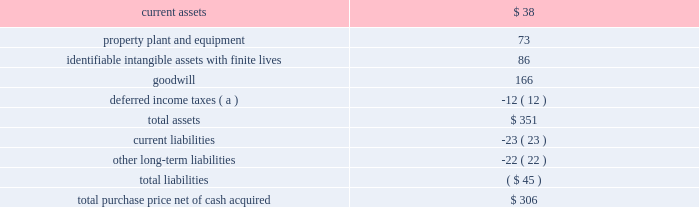58 2018 ppg annual report and 10-k the crown group on october 2 , 2017 , ppg acquired the crown group ( 201ccrown 201d ) , a u.s.-based coatings application services business , which is reported as part of ppg's industrial coatings reportable segment .
Crown is one of the leading component and product finishers in north america .
Crown applies coatings to customers 2019 manufactured parts and assembled products at 11 u.s .
Sites .
Most of crown 2019s facilities , which also provide assembly , warehousing and sequencing services , are located at customer facilities or positioned near customer manufacturing sites .
The company serves manufacturers in the automotive , agriculture , construction , heavy truck and alternative energy industries .
The pro-forma impact on ppg's sales and results of operations , including the pro forma effect of events that are directly attributable to the acquisition , was not significant .
The results of this business since the date of acquisition have been reported within the industrial coatings business within the industrial coatings reportable segment .
Taiwan chlorine industries taiwan chlorine industries ( 201ctci 201d ) was established in 1986 as a joint venture between ppg and china petrochemical development corporation ( 201ccpdc 201d ) to produce chlorine-based products in taiwan , at which time ppg owned 60 percent of the venture .
In conjunction with the 2013 separation of its commodity chemicals business , ppg conveyed to axiall corporation ( "axiall" ) its 60% ( 60 % ) ownership interest in tci .
Under ppg 2019s agreement with cpdc , if certain post-closing conditions were not met following the three year anniversary of the separation , cpdc had the option to sell its 40% ( 40 % ) ownership interest in tci to axiall for $ 100 million .
In turn , axiall had a right to designate ppg as its designee to purchase the 40% ( 40 % ) ownership interest of cpdc .
In april 2016 , axiall announced that cpdc had decided to sell its ownership interest in tci to axiall .
In june 2016 , axiall formally designated ppg to purchase the 40% ( 40 % ) ownership interest in tci .
In august 2016 , westlake chemical corporation acquired axiall , which became a wholly-owned subsidiary of westlake .
In april 2017 , ppg finalized its purchase of cpdc 2019s 40% ( 40 % ) ownership interest in tci .
The difference between the acquisition date fair value and the purchase price of ppg 2019s 40% ( 40 % ) ownership interest in tci has been recorded as a loss in discontinued operations during the year-ended december 31 , 2017 .
Ppg 2019s ownership in tci is accounted for as an equity method investment and the related equity earnings are reported within other income in the consolidated statement of income and in legacy in note 20 , 201creportable business segment information . 201d metokote corporation in july 2016 , ppg completed the acquisition of metokote corporation ( "metokote" ) , a u.s.-based coatings application services business .
Metokote applies coatings to customers' manufactured parts and assembled products .
It operates on- site coatings services within several customer manufacturing locations , as well as at regional service centers , located throughout the u.s. , canada , mexico , the united kingdom , germany , hungary and the czech republic .
Customers ship parts to metokote ae service centers where they are treated to enhance paint adhesion and painted with electrocoat , powder or liquid coatings technologies .
Coated parts are then shipped to the customer 2019s next stage of assembly .
Metokote coats an average of more than 1.5 million parts per day .
The table summarizes the estimated fair value of assets acquired and liabilities assumed as reflected in the final purchase price allocation for metokote .
( $ in millions ) .
( a ) the net deferred income tax liability is included in assets due to the company's tax jurisdictional netting .
The pro-forma impact on ppg's sales and results of operations , including the pro forma effect of events that are directly attributable to the acquisition , was not significant .
While calculating this impact , no cost savings or operating synergies that may result from the acquisition were included .
The results of this business since the date of acquisition have been reported within the industrial coatings business within the industrial coatings reportable segment .
Notes to the consolidated financial statements .
For metokote , what percentage of purchase price was hard assets? 
Rationale: ppe- hard assets
Computations: (73 / 306)
Answer: 0.23856. 58 2018 ppg annual report and 10-k the crown group on october 2 , 2017 , ppg acquired the crown group ( 201ccrown 201d ) , a u.s.-based coatings application services business , which is reported as part of ppg's industrial coatings reportable segment .
Crown is one of the leading component and product finishers in north america .
Crown applies coatings to customers 2019 manufactured parts and assembled products at 11 u.s .
Sites .
Most of crown 2019s facilities , which also provide assembly , warehousing and sequencing services , are located at customer facilities or positioned near customer manufacturing sites .
The company serves manufacturers in the automotive , agriculture , construction , heavy truck and alternative energy industries .
The pro-forma impact on ppg's sales and results of operations , including the pro forma effect of events that are directly attributable to the acquisition , was not significant .
The results of this business since the date of acquisition have been reported within the industrial coatings business within the industrial coatings reportable segment .
Taiwan chlorine industries taiwan chlorine industries ( 201ctci 201d ) was established in 1986 as a joint venture between ppg and china petrochemical development corporation ( 201ccpdc 201d ) to produce chlorine-based products in taiwan , at which time ppg owned 60 percent of the venture .
In conjunction with the 2013 separation of its commodity chemicals business , ppg conveyed to axiall corporation ( "axiall" ) its 60% ( 60 % ) ownership interest in tci .
Under ppg 2019s agreement with cpdc , if certain post-closing conditions were not met following the three year anniversary of the separation , cpdc had the option to sell its 40% ( 40 % ) ownership interest in tci to axiall for $ 100 million .
In turn , axiall had a right to designate ppg as its designee to purchase the 40% ( 40 % ) ownership interest of cpdc .
In april 2016 , axiall announced that cpdc had decided to sell its ownership interest in tci to axiall .
In june 2016 , axiall formally designated ppg to purchase the 40% ( 40 % ) ownership interest in tci .
In august 2016 , westlake chemical corporation acquired axiall , which became a wholly-owned subsidiary of westlake .
In april 2017 , ppg finalized its purchase of cpdc 2019s 40% ( 40 % ) ownership interest in tci .
The difference between the acquisition date fair value and the purchase price of ppg 2019s 40% ( 40 % ) ownership interest in tci has been recorded as a loss in discontinued operations during the year-ended december 31 , 2017 .
Ppg 2019s ownership in tci is accounted for as an equity method investment and the related equity earnings are reported within other income in the consolidated statement of income and in legacy in note 20 , 201creportable business segment information . 201d metokote corporation in july 2016 , ppg completed the acquisition of metokote corporation ( "metokote" ) , a u.s.-based coatings application services business .
Metokote applies coatings to customers' manufactured parts and assembled products .
It operates on- site coatings services within several customer manufacturing locations , as well as at regional service centers , located throughout the u.s. , canada , mexico , the united kingdom , germany , hungary and the czech republic .
Customers ship parts to metokote ae service centers where they are treated to enhance paint adhesion and painted with electrocoat , powder or liquid coatings technologies .
Coated parts are then shipped to the customer 2019s next stage of assembly .
Metokote coats an average of more than 1.5 million parts per day .
The table summarizes the estimated fair value of assets acquired and liabilities assumed as reflected in the final purchase price allocation for metokote .
( $ in millions ) .
( a ) the net deferred income tax liability is included in assets due to the company's tax jurisdictional netting .
The pro-forma impact on ppg's sales and results of operations , including the pro forma effect of events that are directly attributable to the acquisition , was not significant .
While calculating this impact , no cost savings or operating synergies that may result from the acquisition were included .
The results of this business since the date of acquisition have been reported within the industrial coatings business within the industrial coatings reportable segment .
Notes to the consolidated financial statements .
What percent of the total purchase price net of cash acquired was property plant and equipment? 
Computations: (73 / 306)
Answer: 0.23856. 